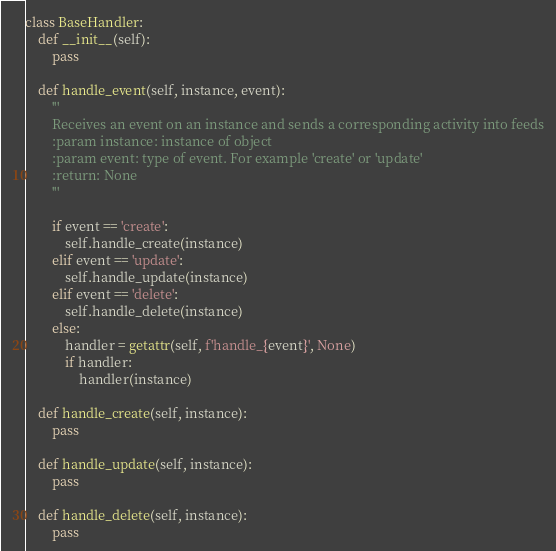<code> <loc_0><loc_0><loc_500><loc_500><_Python_>class BaseHandler:
    def __init__(self):
        pass

    def handle_event(self, instance, event):
        '''
        Receives an event on an instance and sends a corresponding activity into feeds
        :param instance: instance of object
        :param event: type of event. For example 'create' or 'update'
        :return: None
        '''

        if event == 'create':
            self.handle_create(instance)
        elif event == 'update':
            self.handle_update(instance)
        elif event == 'delete':
            self.handle_delete(instance)
        else:
            handler = getattr(self, f'handle_{event}', None)
            if handler:
                handler(instance)

    def handle_create(self, instance):
        pass

    def handle_update(self, instance):
        pass

    def handle_delete(self, instance):
        pass
</code> 